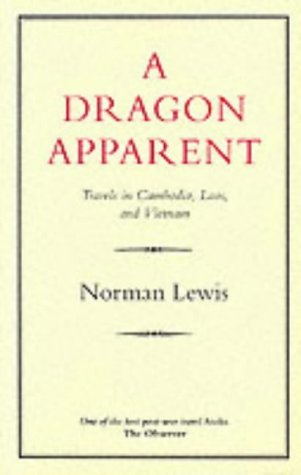What countries does Norman Lewis travel to in this book? In 'A Dragon Apparent', Norman Lewis travels through Cambodia, Laos, and Vietnam, offering a deep dive into the culture and landscapes of these countries. 